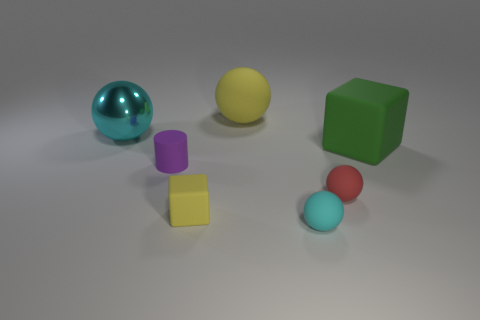How many other things are there of the same color as the big shiny ball?
Your answer should be very brief. 1. Do the cyan metal ball and the cyan thing right of the purple object have the same size?
Give a very brief answer. No. There is a cyan thing behind the matte thing that is on the left side of the small rubber block; is there a large cyan metal ball behind it?
Keep it short and to the point. No. There is a cyan thing behind the red object that is in front of the yellow ball; what is it made of?
Offer a terse response. Metal. There is a big thing that is both in front of the large yellow rubber sphere and to the left of the red matte thing; what material is it?
Make the answer very short. Metal. Are there any other cyan objects that have the same shape as the tiny cyan matte thing?
Offer a very short reply. Yes. There is a tiny object left of the small matte cube; is there a matte cylinder that is on the left side of it?
Make the answer very short. No. How many cylinders have the same material as the red thing?
Your answer should be very brief. 1. Are there any big cyan metal spheres?
Provide a short and direct response. Yes. What number of tiny blocks have the same color as the big metallic thing?
Make the answer very short. 0. 